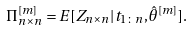<formula> <loc_0><loc_0><loc_500><loc_500>\Pi ^ { [ m ] } _ { n \times n } = E [ Z _ { n \times n } | t _ { 1 \colon n } , \hat { \theta } ^ { [ m ] } ] .</formula> 